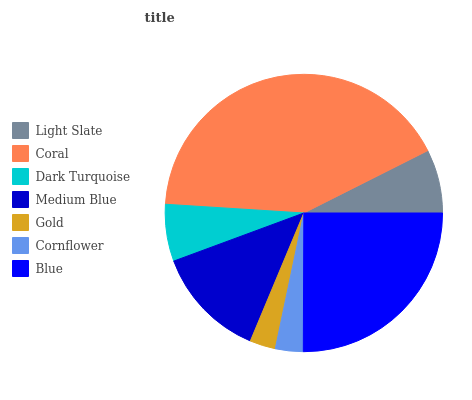Is Gold the minimum?
Answer yes or no. Yes. Is Coral the maximum?
Answer yes or no. Yes. Is Dark Turquoise the minimum?
Answer yes or no. No. Is Dark Turquoise the maximum?
Answer yes or no. No. Is Coral greater than Dark Turquoise?
Answer yes or no. Yes. Is Dark Turquoise less than Coral?
Answer yes or no. Yes. Is Dark Turquoise greater than Coral?
Answer yes or no. No. Is Coral less than Dark Turquoise?
Answer yes or no. No. Is Light Slate the high median?
Answer yes or no. Yes. Is Light Slate the low median?
Answer yes or no. Yes. Is Dark Turquoise the high median?
Answer yes or no. No. Is Gold the low median?
Answer yes or no. No. 